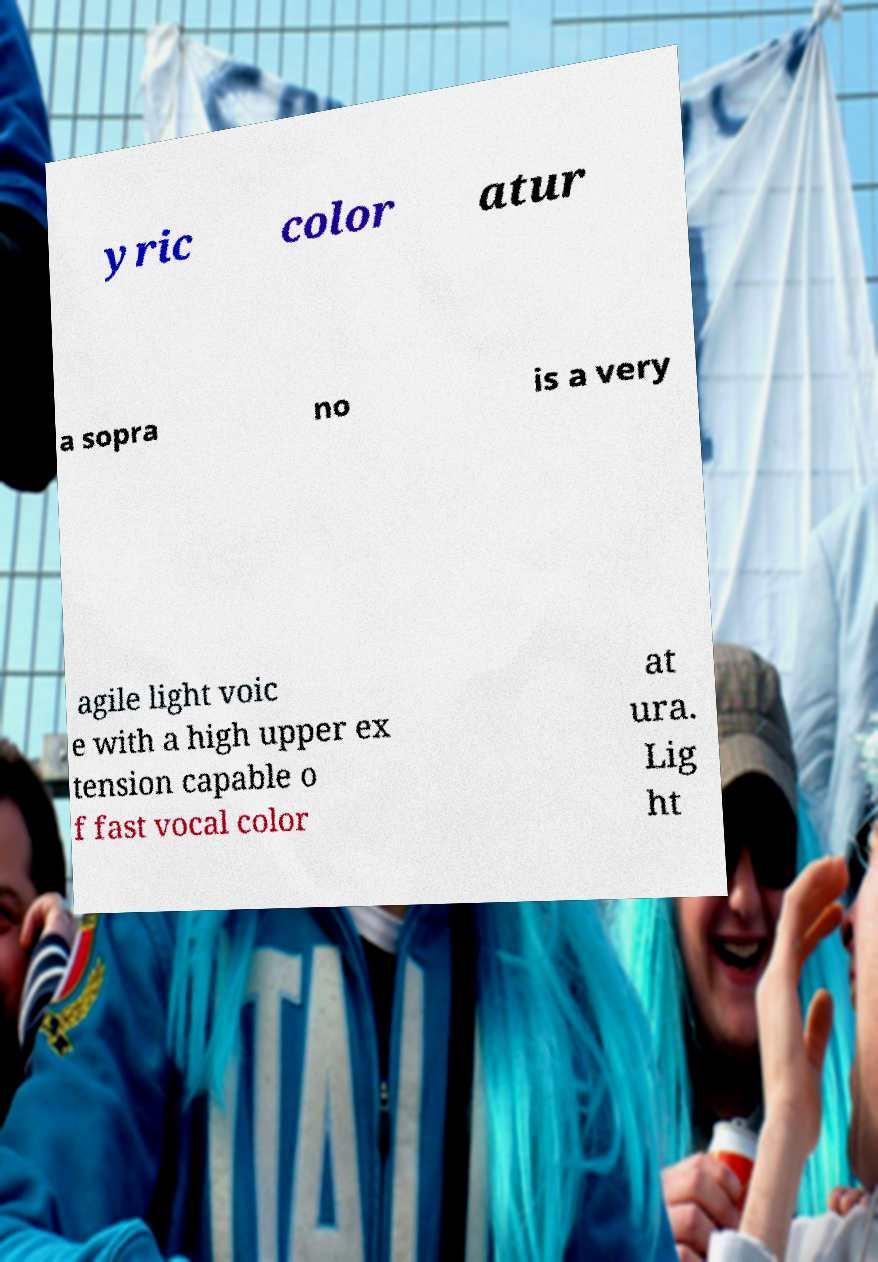Could you assist in decoding the text presented in this image and type it out clearly? yric color atur a sopra no is a very agile light voic e with a high upper ex tension capable o f fast vocal color at ura. Lig ht 